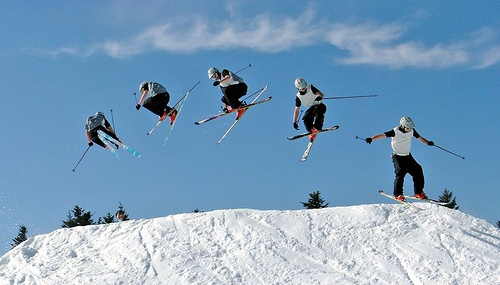Describe the objects in this image and their specific colors. I can see people in gray, black, and darkgray tones, people in gray, black, and darkgray tones, people in gray, black, darkgray, and blue tones, people in gray, black, and darkgray tones, and people in gray, black, and blue tones in this image. 